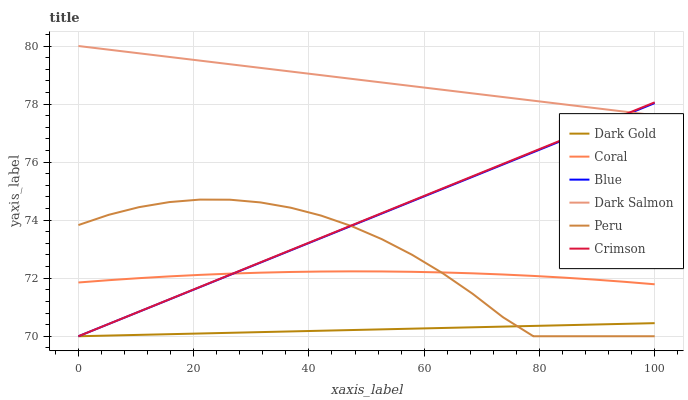Does Dark Gold have the minimum area under the curve?
Answer yes or no. Yes. Does Dark Salmon have the maximum area under the curve?
Answer yes or no. Yes. Does Coral have the minimum area under the curve?
Answer yes or no. No. Does Coral have the maximum area under the curve?
Answer yes or no. No. Is Dark Gold the smoothest?
Answer yes or no. Yes. Is Peru the roughest?
Answer yes or no. Yes. Is Coral the smoothest?
Answer yes or no. No. Is Coral the roughest?
Answer yes or no. No. Does Coral have the lowest value?
Answer yes or no. No. Does Dark Salmon have the highest value?
Answer yes or no. Yes. Does Coral have the highest value?
Answer yes or no. No. Is Dark Gold less than Coral?
Answer yes or no. Yes. Is Coral greater than Dark Gold?
Answer yes or no. Yes. Does Peru intersect Blue?
Answer yes or no. Yes. Is Peru less than Blue?
Answer yes or no. No. Is Peru greater than Blue?
Answer yes or no. No. Does Dark Gold intersect Coral?
Answer yes or no. No. 